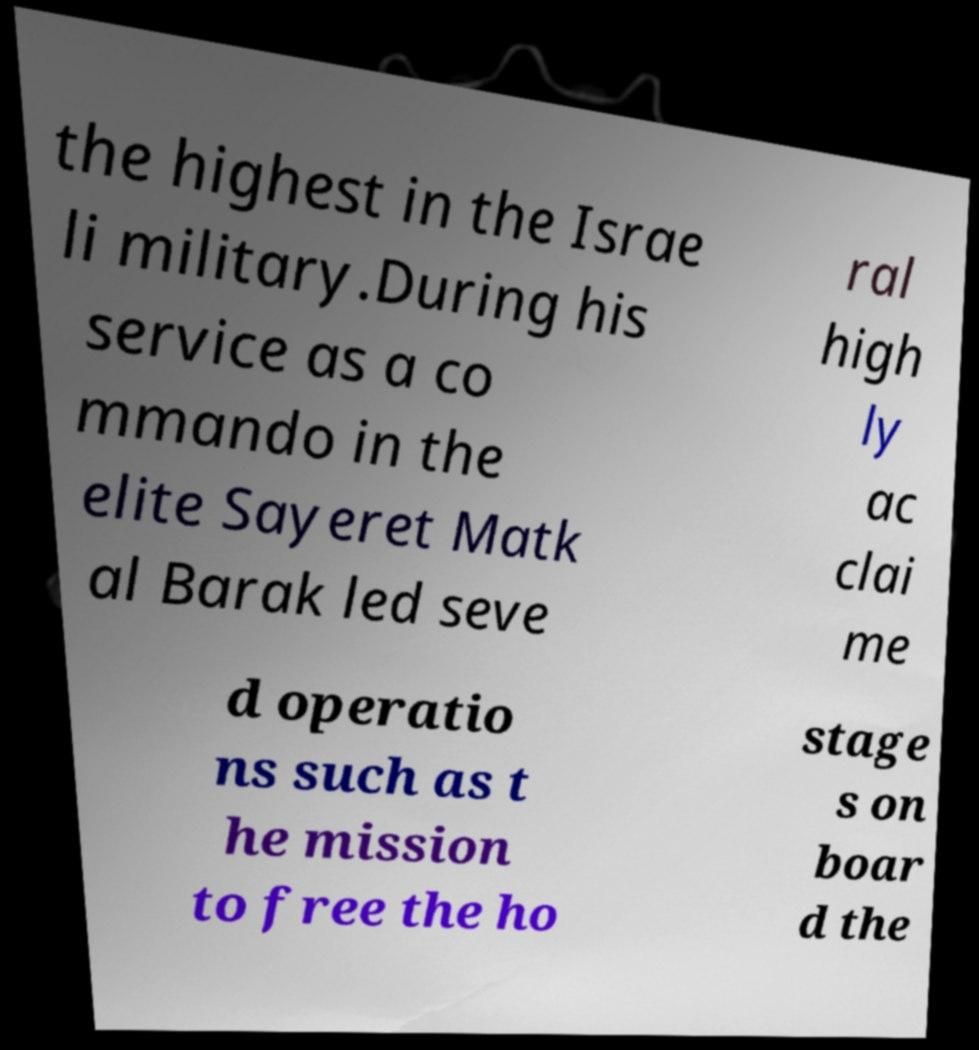There's text embedded in this image that I need extracted. Can you transcribe it verbatim? the highest in the Israe li military.During his service as a co mmando in the elite Sayeret Matk al Barak led seve ral high ly ac clai me d operatio ns such as t he mission to free the ho stage s on boar d the 